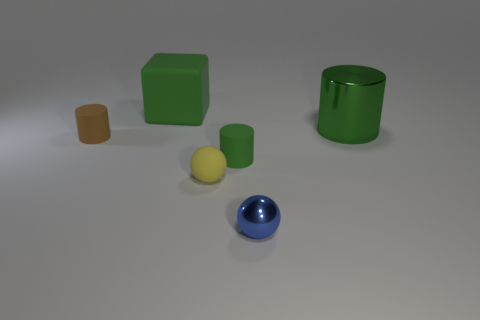What size is the block that is the same color as the big cylinder?
Your answer should be very brief. Large. The other sphere that is the same size as the yellow rubber sphere is what color?
Provide a succinct answer. Blue. How many yellow objects have the same shape as the blue object?
Your answer should be compact. 1. What number of blocks are big red shiny objects or tiny objects?
Offer a very short reply. 0. There is a metal object to the left of the green metal thing; is its shape the same as the big object that is on the right side of the small blue shiny ball?
Give a very brief answer. No. What material is the blue ball?
Give a very brief answer. Metal. There is a large metallic thing that is the same color as the large matte thing; what is its shape?
Offer a very short reply. Cylinder. How many yellow matte spheres have the same size as the green shiny cylinder?
Your answer should be compact. 0. How many objects are either rubber objects that are to the left of the green matte block or green things that are behind the shiny cylinder?
Provide a short and direct response. 2. Are the ball in front of the yellow sphere and the green cylinder that is in front of the green metallic thing made of the same material?
Offer a terse response. No. 